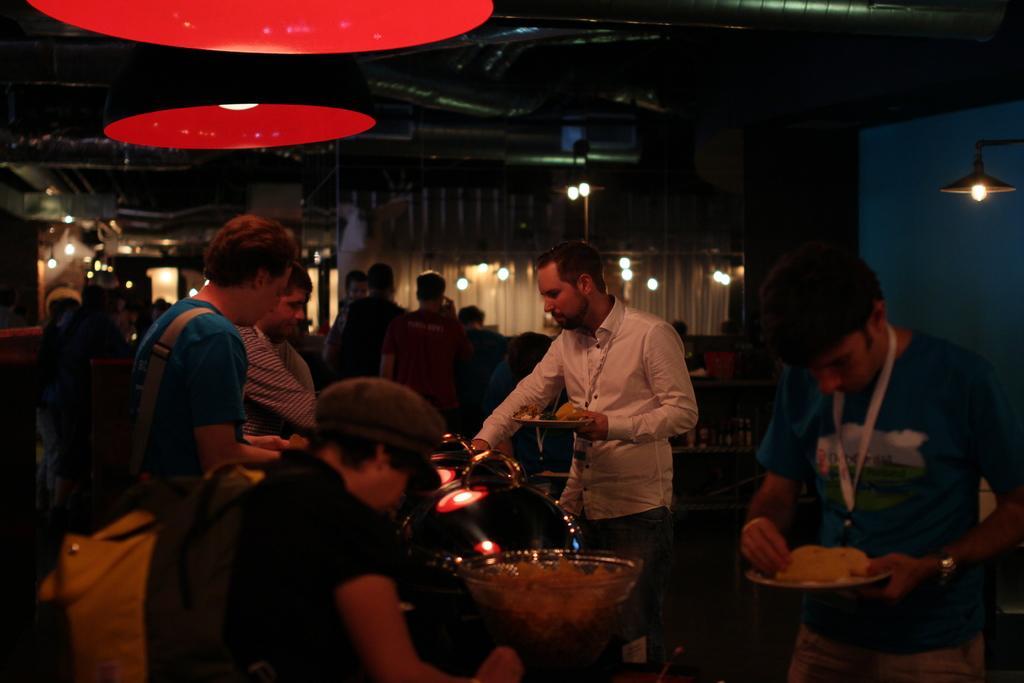Describe this image in one or two sentences. As we can see in the image there are few people, lights, bowls and in the background there are curtains. On the right side there is blue color wall and the image is little dark. 